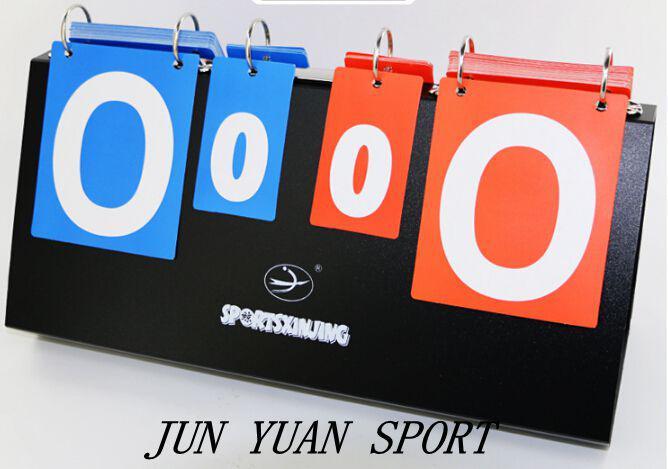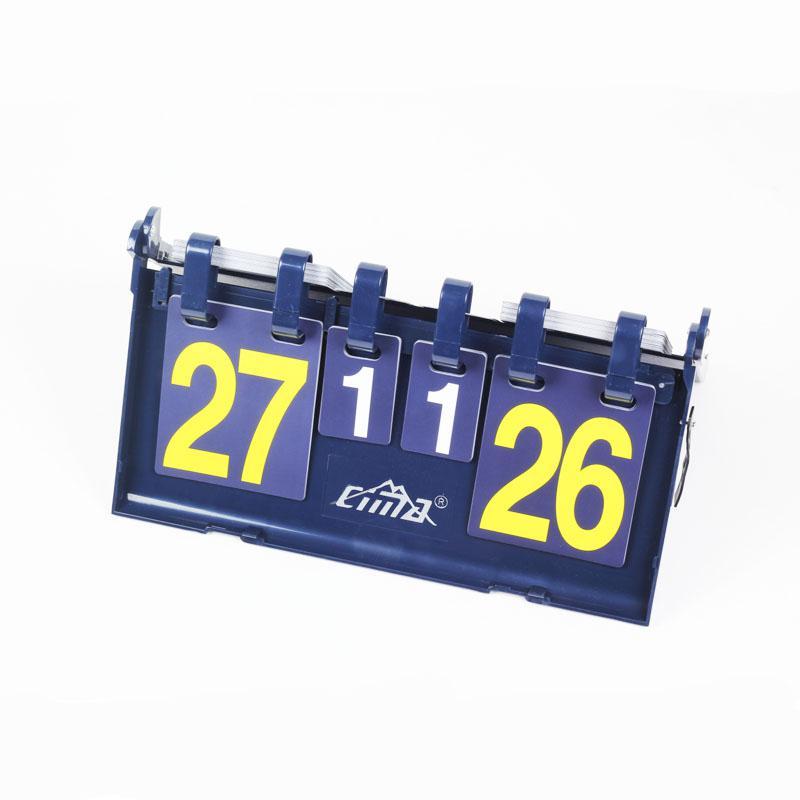The first image is the image on the left, the second image is the image on the right. Evaluate the accuracy of this statement regarding the images: "In at least one image there is a total of four zeros.". Is it true? Answer yes or no. Yes. The first image is the image on the left, the second image is the image on the right. Examine the images to the left and right. Is the description "There are eight rings in the left image." accurate? Answer yes or no. No. 